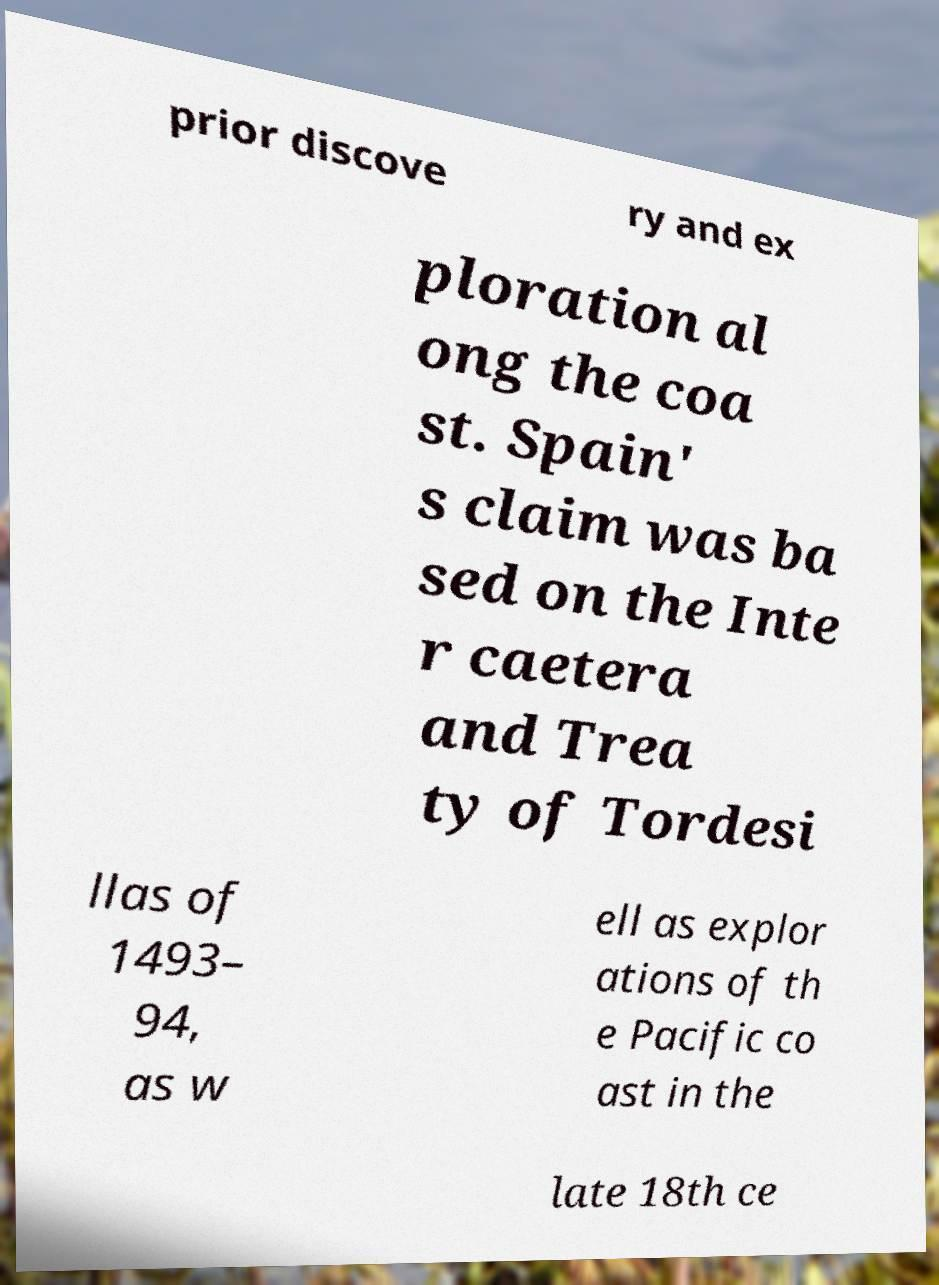I need the written content from this picture converted into text. Can you do that? prior discove ry and ex ploration al ong the coa st. Spain' s claim was ba sed on the Inte r caetera and Trea ty of Tordesi llas of 1493– 94, as w ell as explor ations of th e Pacific co ast in the late 18th ce 